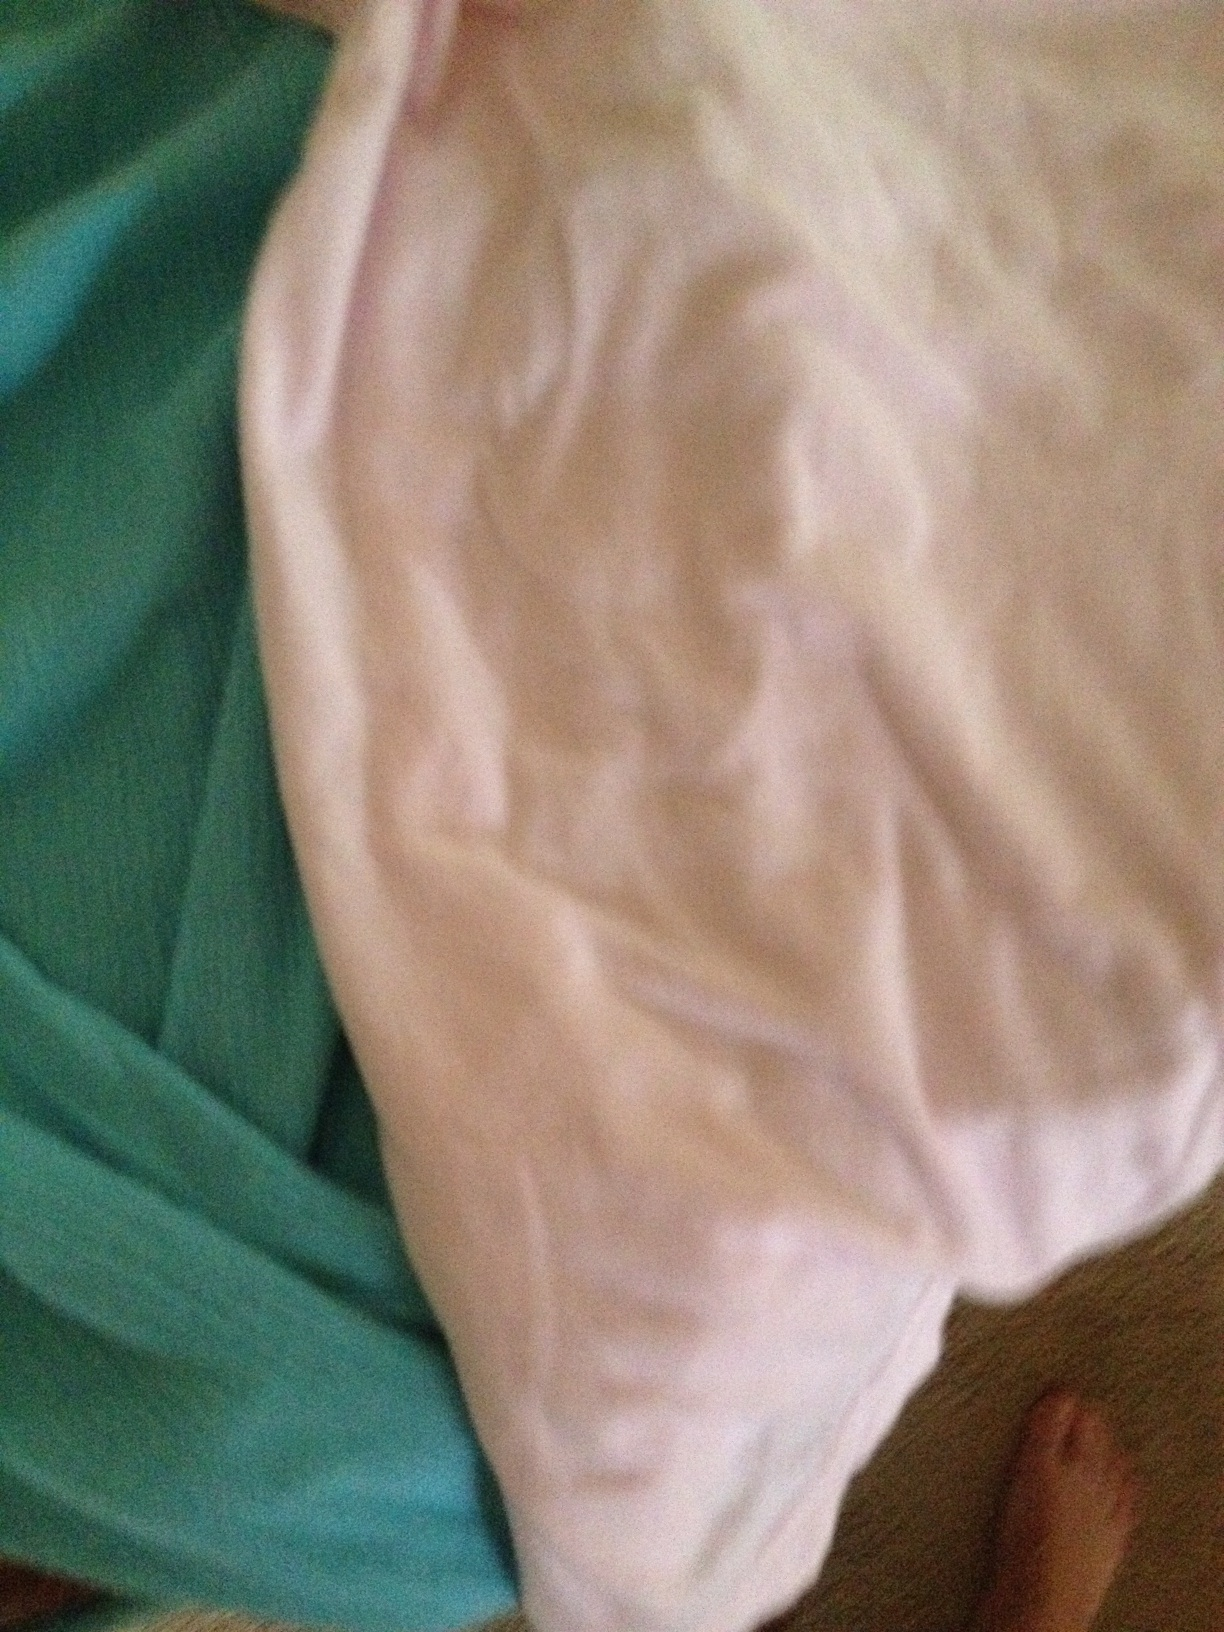What do you think these items are? The image shows two fabric items, one in teal and the other in white. They appear to be pieces of cloth, possibly clothing or bed linens like sheets or duvet covers. Do you have more information or a second image for better context? Could these be part of an outfit? It's possible. The teal and white colors could be part of a coordinated outfit, maybe a top and a bottom or a scarf and a shirt. However, it's difficult to confirm without seeing more of the items or knowing their specific designs. 